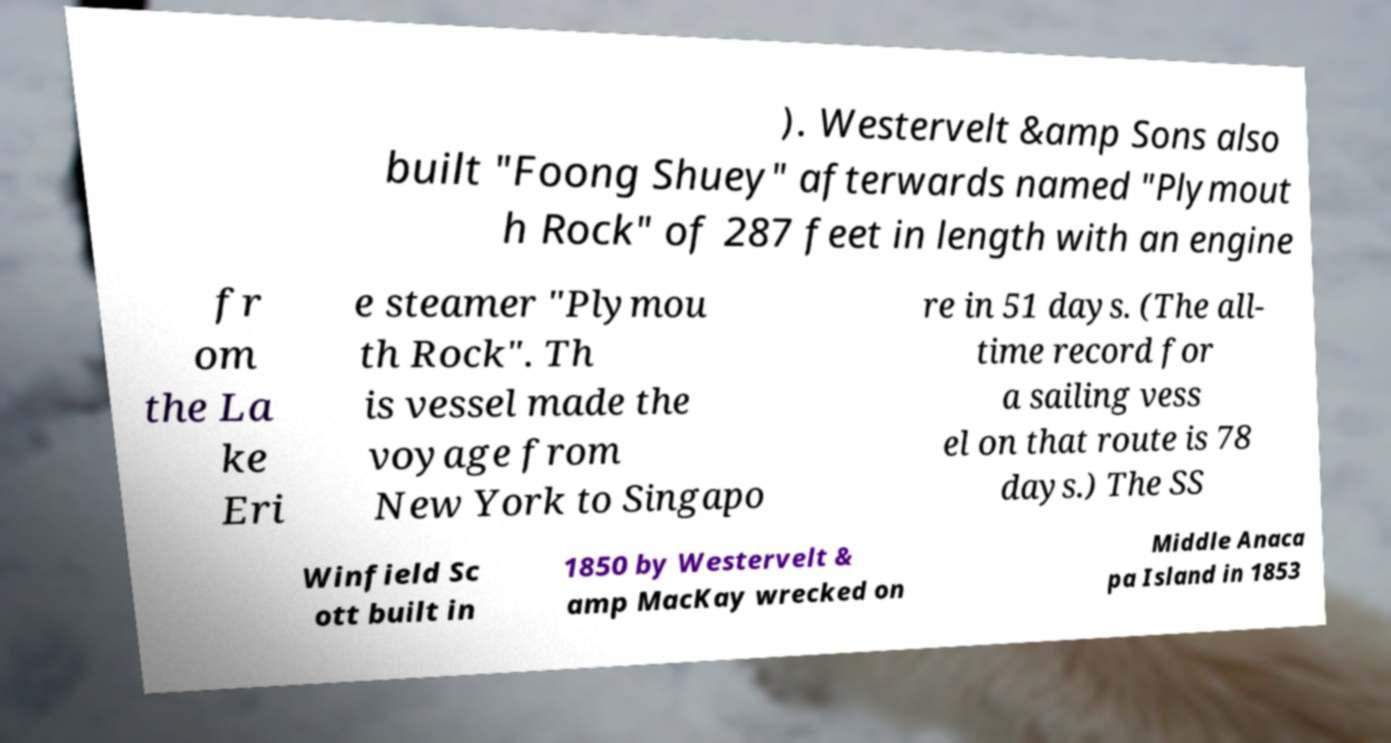Please read and relay the text visible in this image. What does it say? ). Westervelt &amp Sons also built "Foong Shuey" afterwards named "Plymout h Rock" of 287 feet in length with an engine fr om the La ke Eri e steamer "Plymou th Rock". Th is vessel made the voyage from New York to Singapo re in 51 days. (The all- time record for a sailing vess el on that route is 78 days.) The SS Winfield Sc ott built in 1850 by Westervelt & amp MacKay wrecked on Middle Anaca pa Island in 1853 